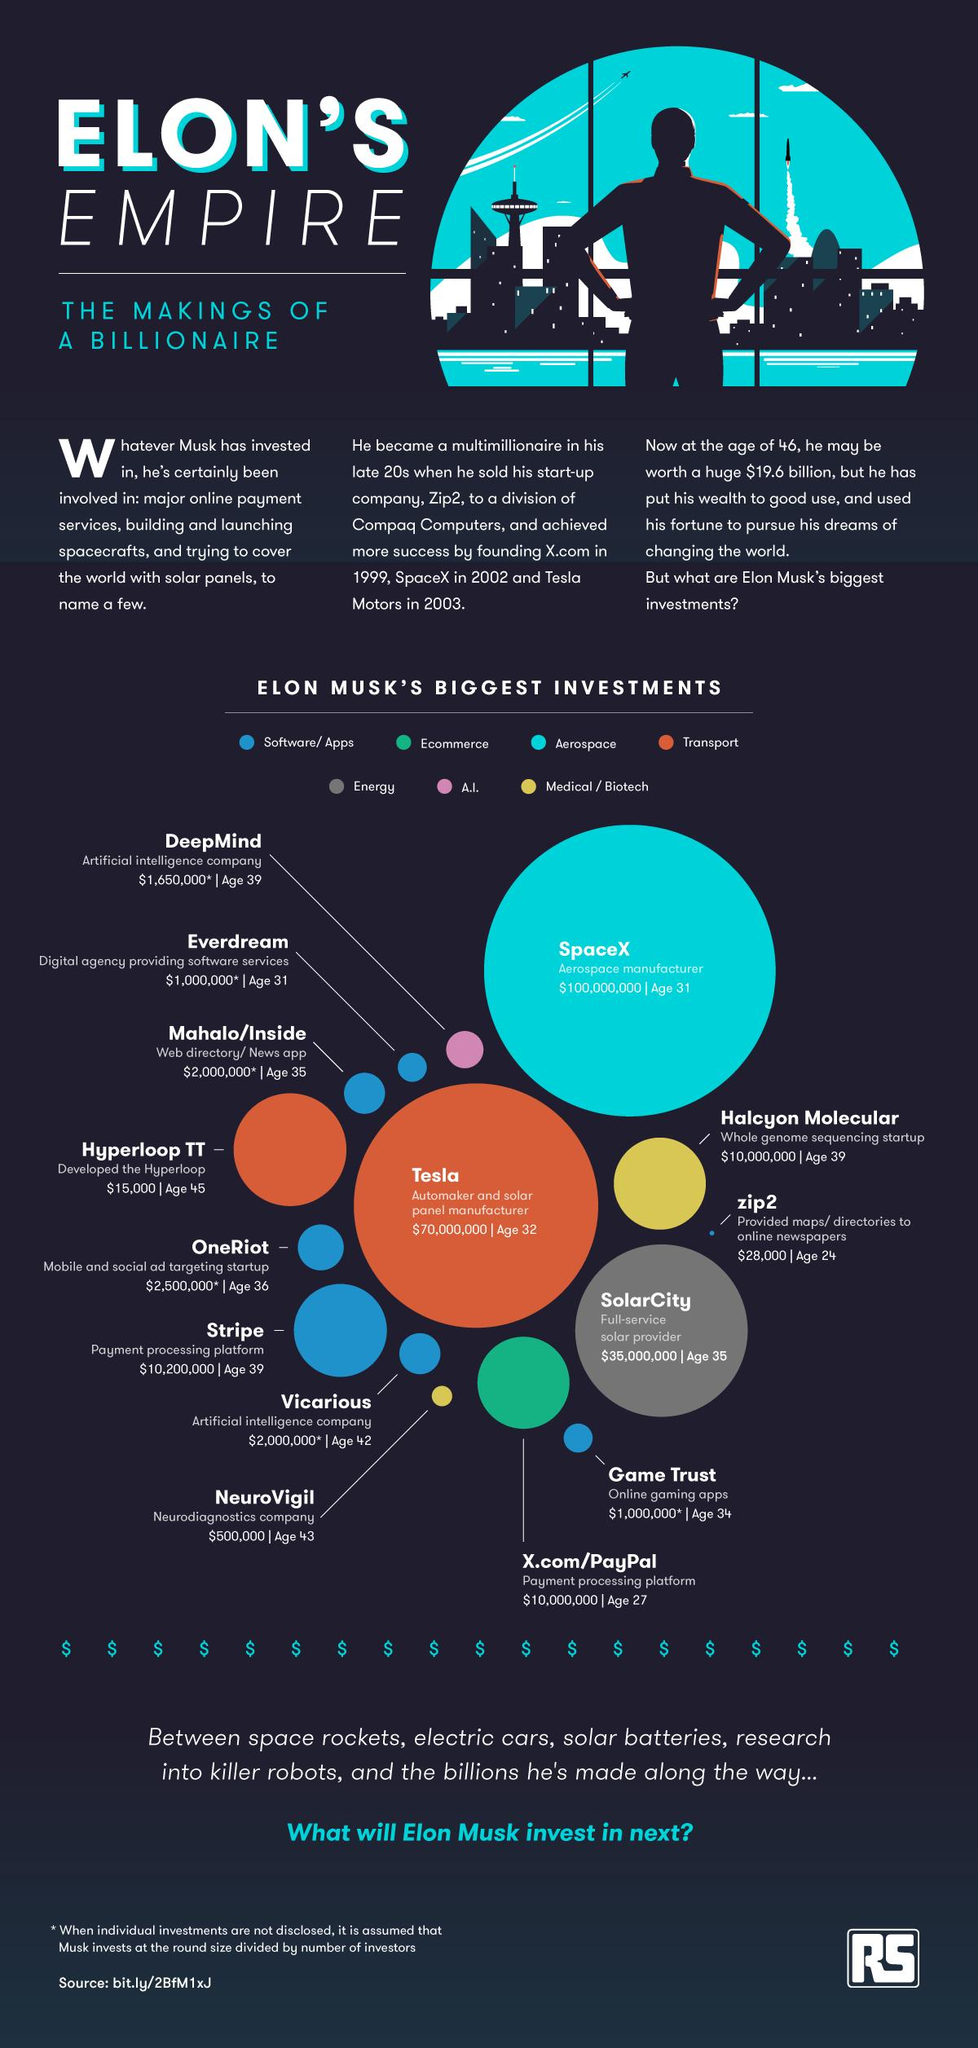Give some essential details in this illustration. It is reported that Elon Musk's largest investment is in the aerospace industry. 